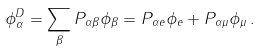Convert formula to latex. <formula><loc_0><loc_0><loc_500><loc_500>\phi ^ { D } _ { \alpha } = \sum _ { \beta } P _ { \alpha \beta } \phi _ { \beta } = P _ { \alpha e } \phi _ { e } + P _ { \alpha \mu } \phi _ { \mu } \, .</formula> 